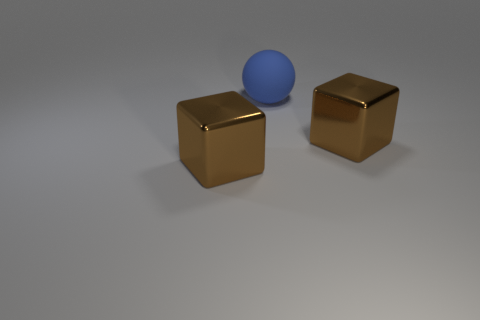Is there anything else that has the same shape as the big rubber object?
Give a very brief answer. No. How many other rubber balls are the same size as the blue rubber sphere?
Provide a succinct answer. 0. How many brown objects are either large shiny objects or big things?
Offer a terse response. 2. What number of objects are either cubes or large blocks that are left of the large matte thing?
Keep it short and to the point. 2. There is a large brown block left of the big blue matte thing; what is its material?
Offer a very short reply. Metal. Is there a metallic object that has the same shape as the big rubber object?
Your answer should be very brief. No. Does the sphere have the same material as the brown cube that is left of the blue sphere?
Provide a short and direct response. No. There is a large thing that is in front of the brown object that is right of the matte thing; what is its material?
Your response must be concise. Metal. Are there more things right of the blue matte sphere than brown blocks?
Make the answer very short. No. Is there a big cyan matte thing?
Keep it short and to the point. No. 